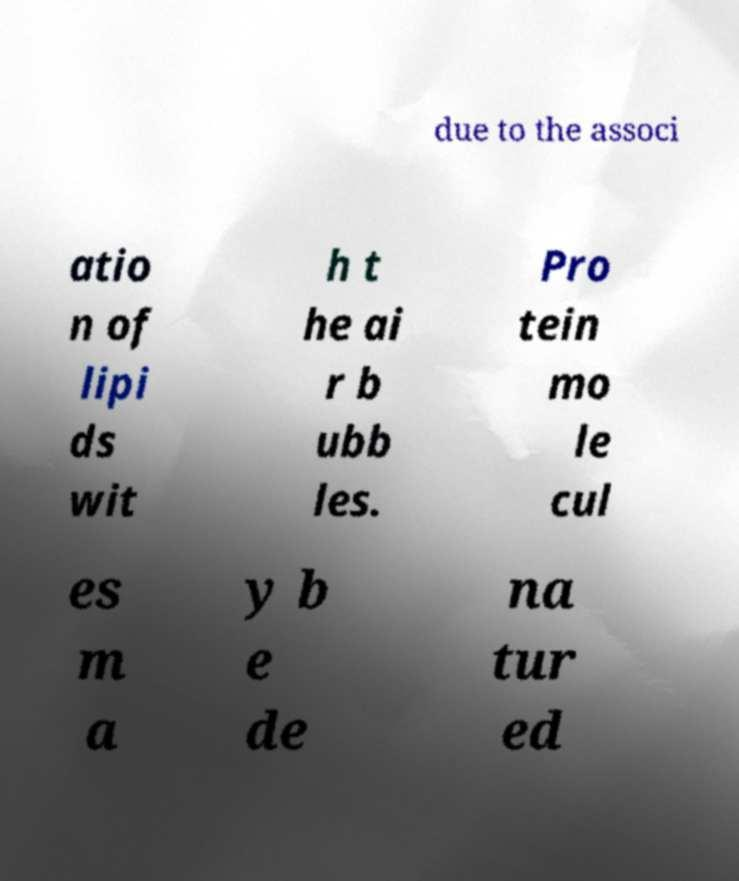Please read and relay the text visible in this image. What does it say? due to the associ atio n of lipi ds wit h t he ai r b ubb les. Pro tein mo le cul es m a y b e de na tur ed 